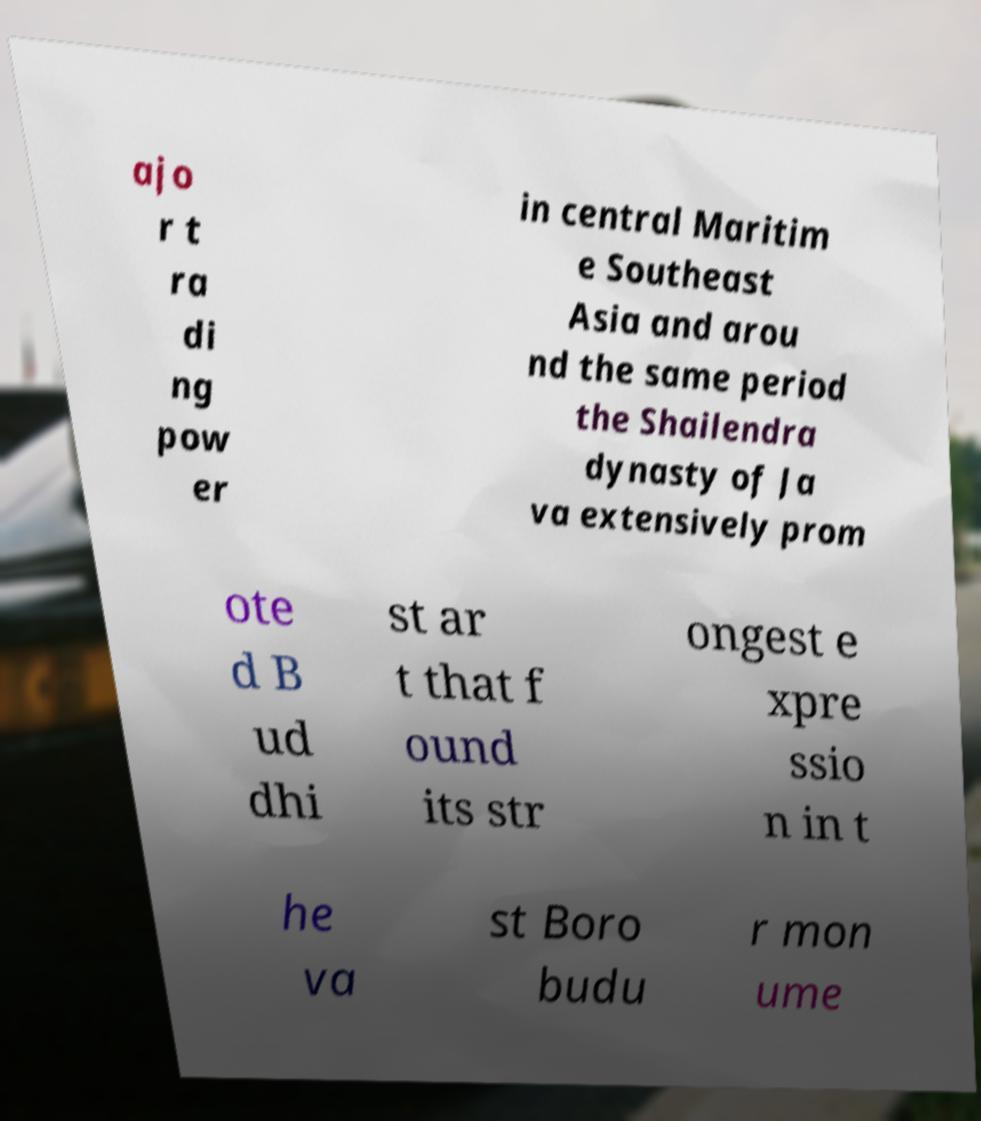For documentation purposes, I need the text within this image transcribed. Could you provide that? ajo r t ra di ng pow er in central Maritim e Southeast Asia and arou nd the same period the Shailendra dynasty of Ja va extensively prom ote d B ud dhi st ar t that f ound its str ongest e xpre ssio n in t he va st Boro budu r mon ume 